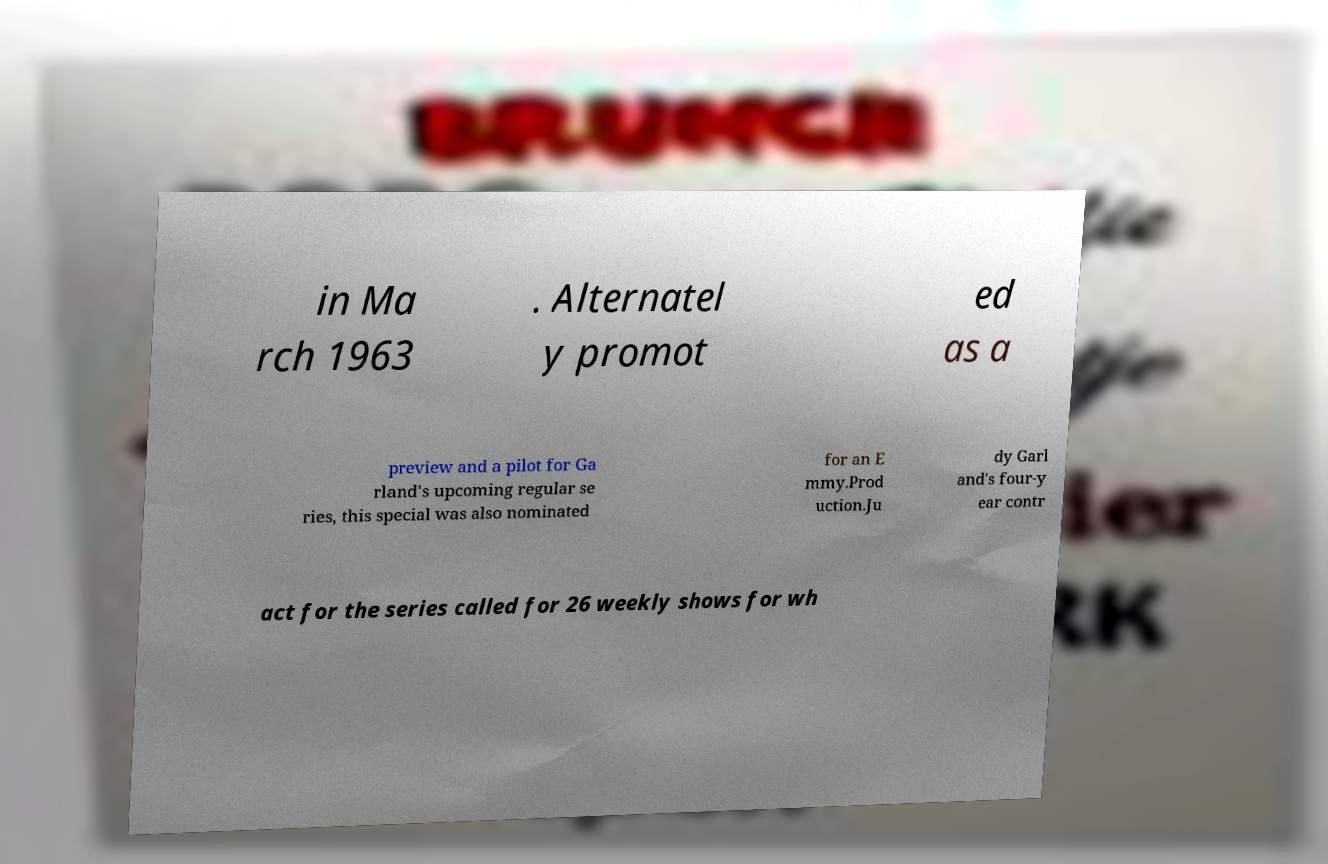What messages or text are displayed in this image? I need them in a readable, typed format. in Ma rch 1963 . Alternatel y promot ed as a preview and a pilot for Ga rland's upcoming regular se ries, this special was also nominated for an E mmy.Prod uction.Ju dy Garl and's four-y ear contr act for the series called for 26 weekly shows for wh 